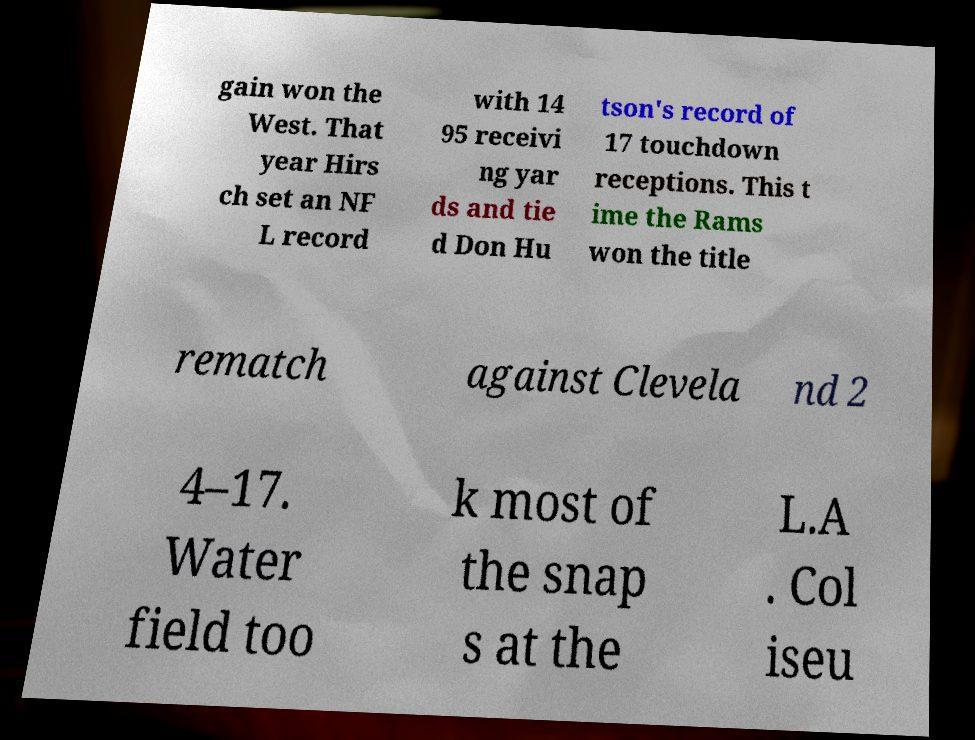There's text embedded in this image that I need extracted. Can you transcribe it verbatim? gain won the West. That year Hirs ch set an NF L record with 14 95 receivi ng yar ds and tie d Don Hu tson's record of 17 touchdown receptions. This t ime the Rams won the title rematch against Clevela nd 2 4–17. Water field too k most of the snap s at the L.A . Col iseu 